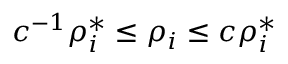Convert formula to latex. <formula><loc_0><loc_0><loc_500><loc_500>c ^ { - 1 } \rho _ { i } ^ { * } \leq \rho _ { i } \leq c \rho _ { i } ^ { * }</formula> 